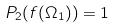<formula> <loc_0><loc_0><loc_500><loc_500>P _ { 2 } ( f ( \Omega _ { 1 } ) ) = 1</formula> 